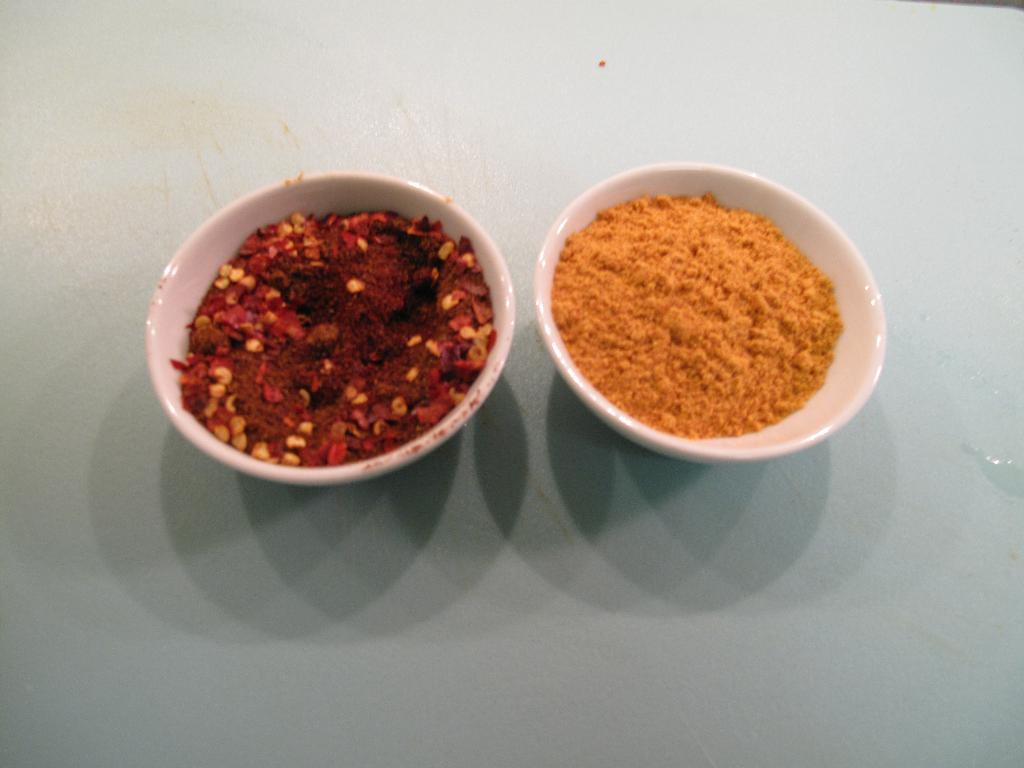What types of containers are present in the image? There are different bowls in the image. What is inside the bowls? The bowls contain spices. Where are the bowls located? The bowls are placed on a surface. What type of sofa can be seen in the image? There is no sofa present in the image; it features different bowls containing spices placed on a surface. 